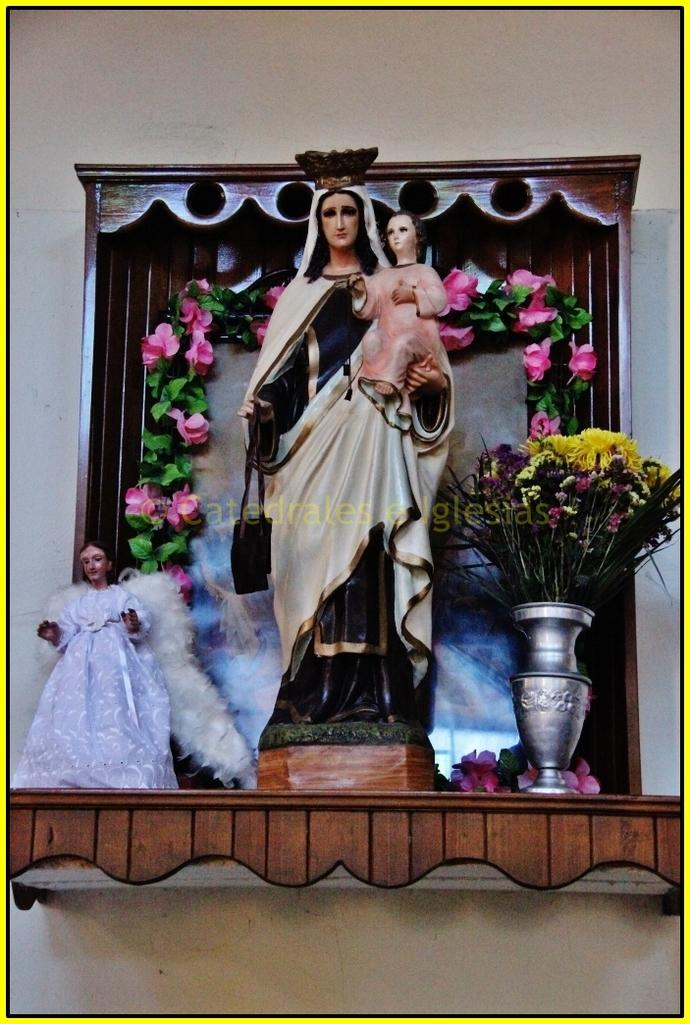What is the main subject in the image? There is a statue in the image. What can be seen on the right side of the image? There is a flower vase on the right side of the image. What type of plants are present in the image? There are flowers and leaves in the image. What is written or depicted in the middle of the image? There is some text in the middle of the image. What is visible in the background of the image? There is a wall in the background of the image. What type of vacation is being advertised in the image? There is no vacation being advertised in the image; it features a statue, a flower vase, flowers, leaves, text, and a wall in the background. 